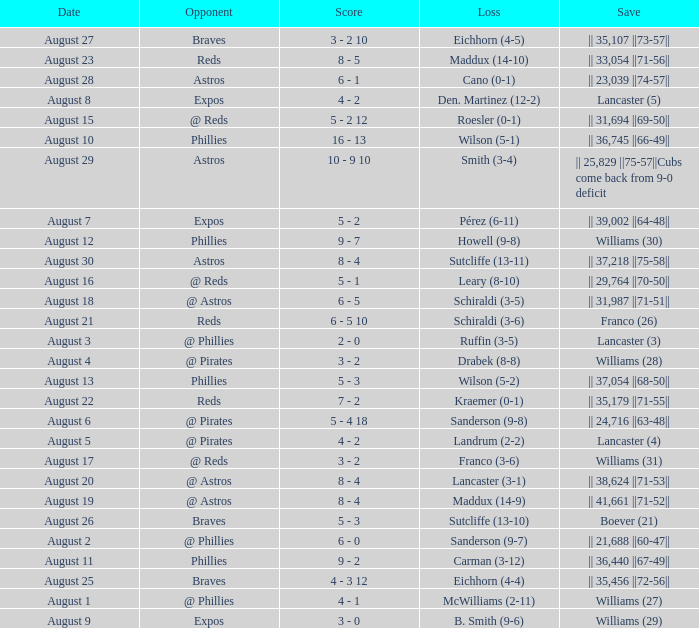Name the date with loss of carman (3-12) August 11. 